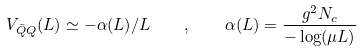Convert formula to latex. <formula><loc_0><loc_0><loc_500><loc_500>V _ { \bar { Q } Q } ( L ) \simeq - \alpha ( L ) / L \quad , \quad \alpha ( L ) = \frac { g ^ { 2 } N _ { c } } { - \log ( \mu L ) }</formula> 